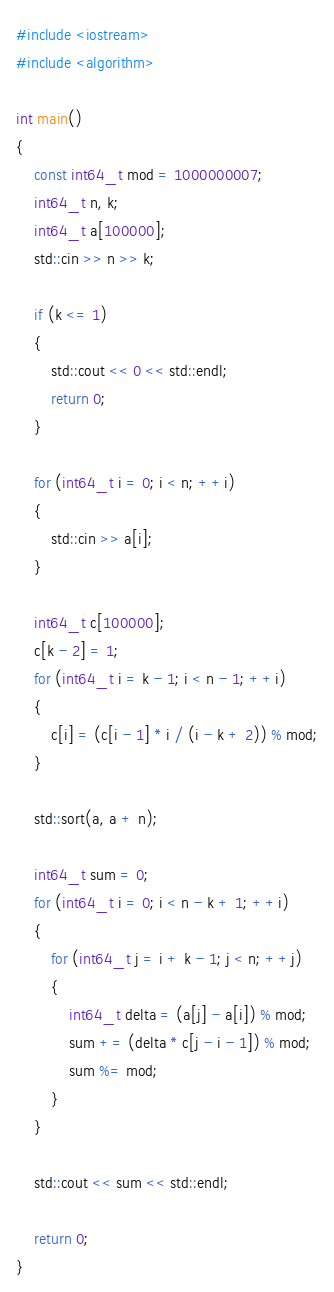Convert code to text. <code><loc_0><loc_0><loc_500><loc_500><_C++_>#include <iostream>
#include <algorithm>

int main()
{
    const int64_t mod = 1000000007;
    int64_t n, k;
    int64_t a[100000];
    std::cin >> n >> k;

    if (k <= 1)
    {
        std::cout << 0 << std::endl;
        return 0;
    }

    for (int64_t i = 0; i < n; ++i)
    {
        std::cin >> a[i];
    }

    int64_t c[100000];
    c[k - 2] = 1;
    for (int64_t i = k - 1; i < n - 1; ++i)
    {
        c[i] = (c[i - 1] * i / (i - k + 2)) % mod;
    }

    std::sort(a, a + n);

    int64_t sum = 0;
    for (int64_t i = 0; i < n - k + 1; ++i)
    {
        for (int64_t j = i + k - 1; j < n; ++j)
        {
            int64_t delta = (a[j] - a[i]) % mod;
            sum += (delta * c[j - i - 1]) % mod;
            sum %= mod;
        }
    }

    std::cout << sum << std::endl;

    return 0;
}</code> 